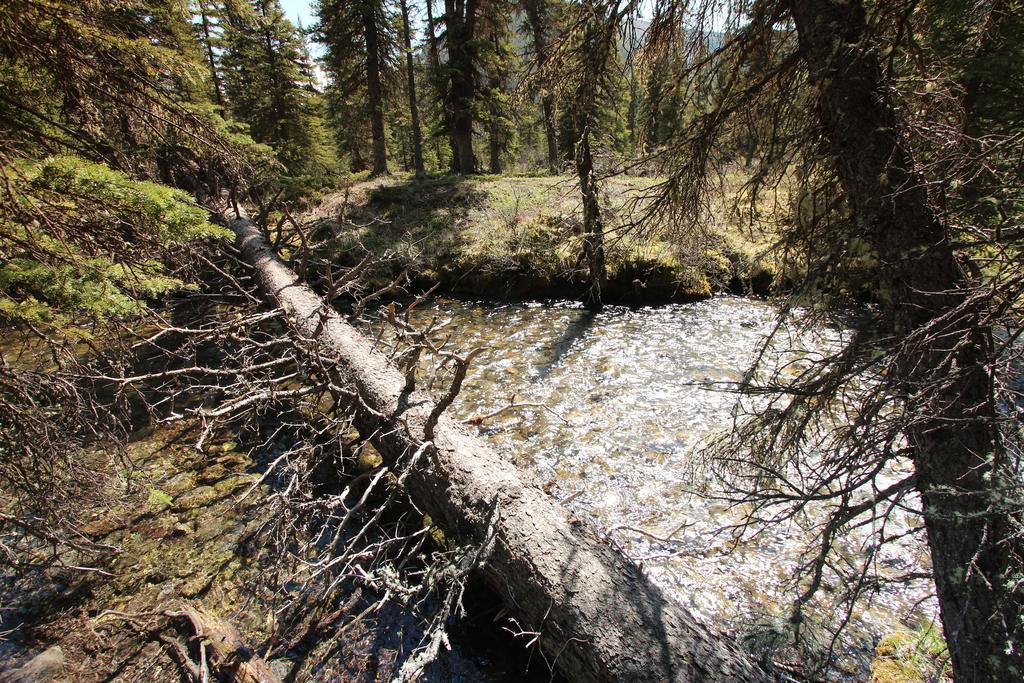In one or two sentences, can you explain what this image depicts? This image is clicked outside. There are trees in this image. There is water in the middle. There are plants and bushes in the middle. There is grass in this image. There is sky at the top. 